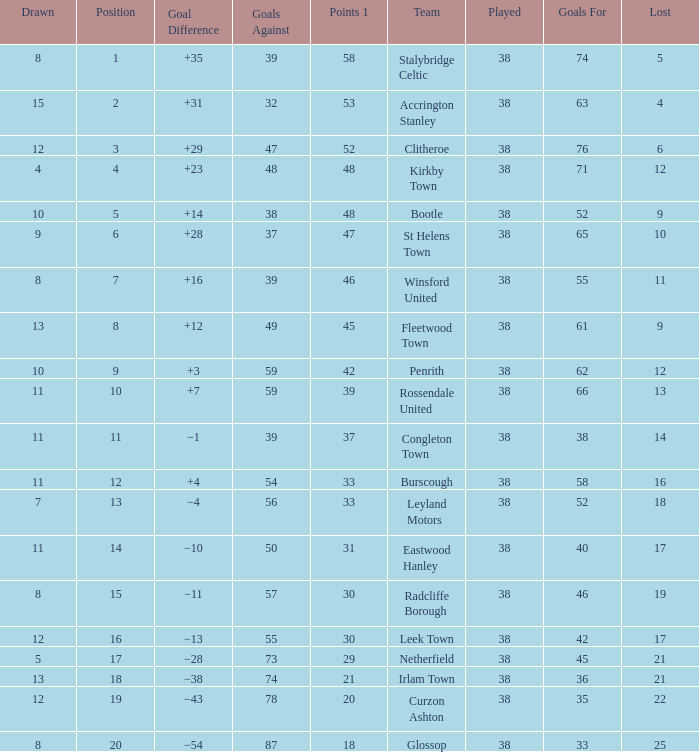What is the total number of losses for a draw of 7, and 1 points less than 33? 0.0. 